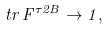<formula> <loc_0><loc_0><loc_500><loc_500>t r \, F ^ { \tau 2 B } \rightarrow 1 ,</formula> 